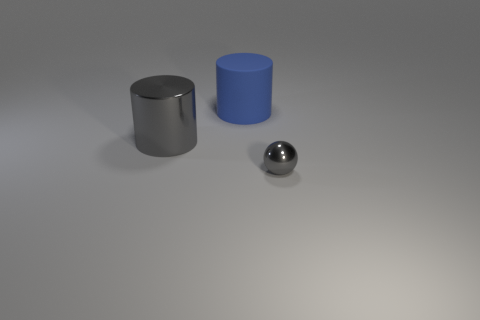Add 1 brown metallic cylinders. How many objects exist? 4 Subtract all cylinders. How many objects are left? 1 Subtract all large green spheres. Subtract all tiny gray shiny balls. How many objects are left? 2 Add 2 gray objects. How many gray objects are left? 4 Add 3 red rubber balls. How many red rubber balls exist? 3 Subtract 0 yellow blocks. How many objects are left? 3 